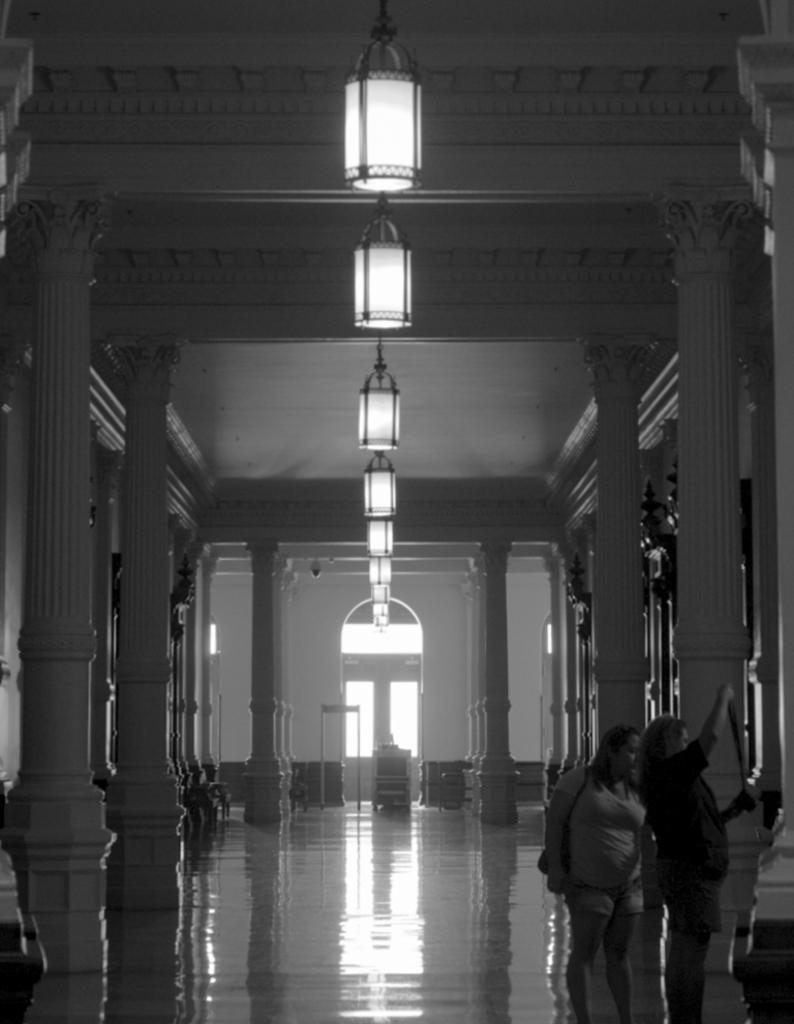Can you describe this image briefly? In the bottom left there is a woman who is wearing t-shirt, bag, short and shoe. Beside her we can see another woman who is wearing black dress and she is holding something in her hand. On the left we can see the pillars. At the top we can see many chandelier which is hanging from the roof. In the background we can see some wooden tables and door. 